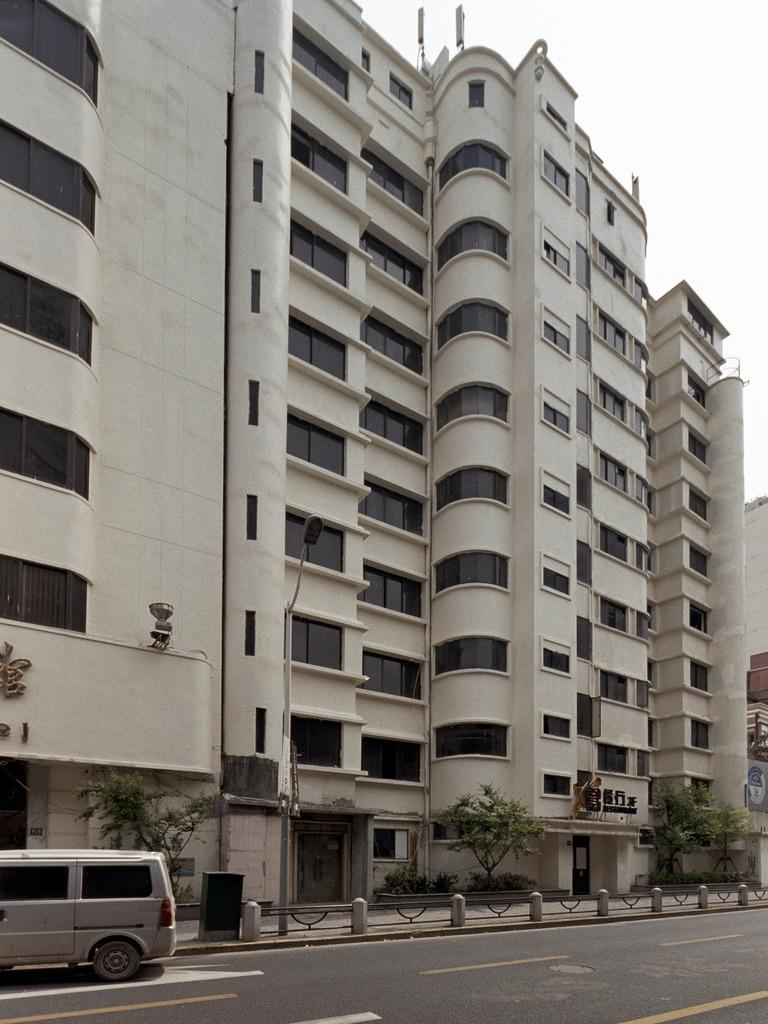What is on the road in the image? There is a vehicle on the road in the image. What can be seen near the road in the image? There is a fence in the image. What type of vegetation is present in the image? There are trees in the image. What type of structures can be seen in the image? There are buildings in the image. What is visible in the background of the image? The sky is visible in the background of the image. Where is the quartz located in the image? There is no quartz present in the image. What color is the rose on the tray in the image? There is no rose or tray present in the image. 